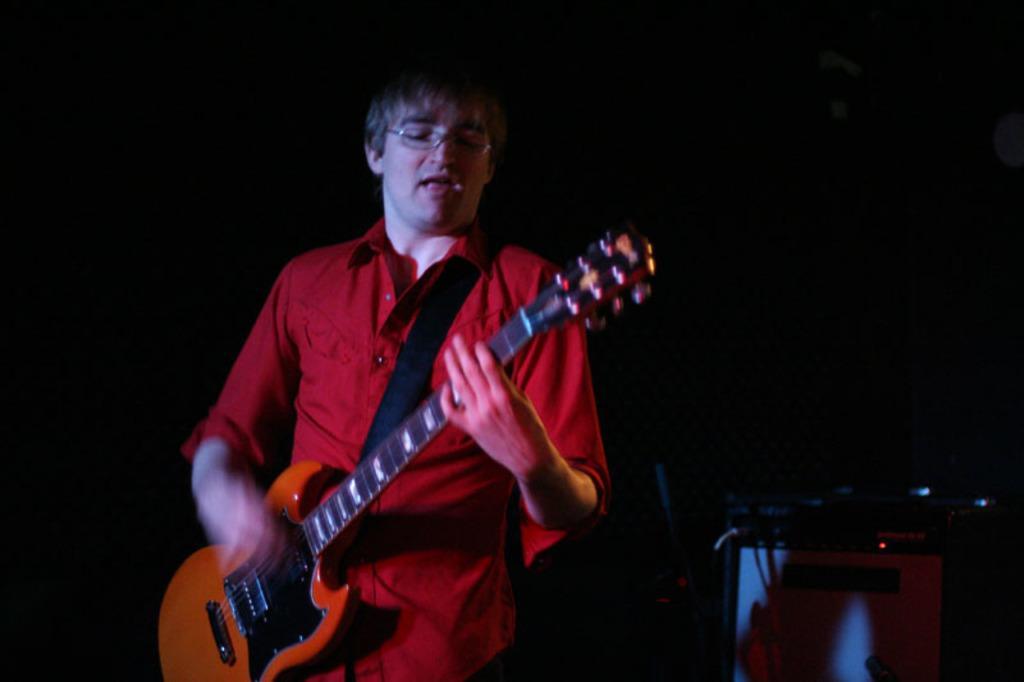In one or two sentences, can you explain what this image depicts? In this image there is a man wearing red color shirt and playing guitar. In the right there is an object with wires. Background is black. 